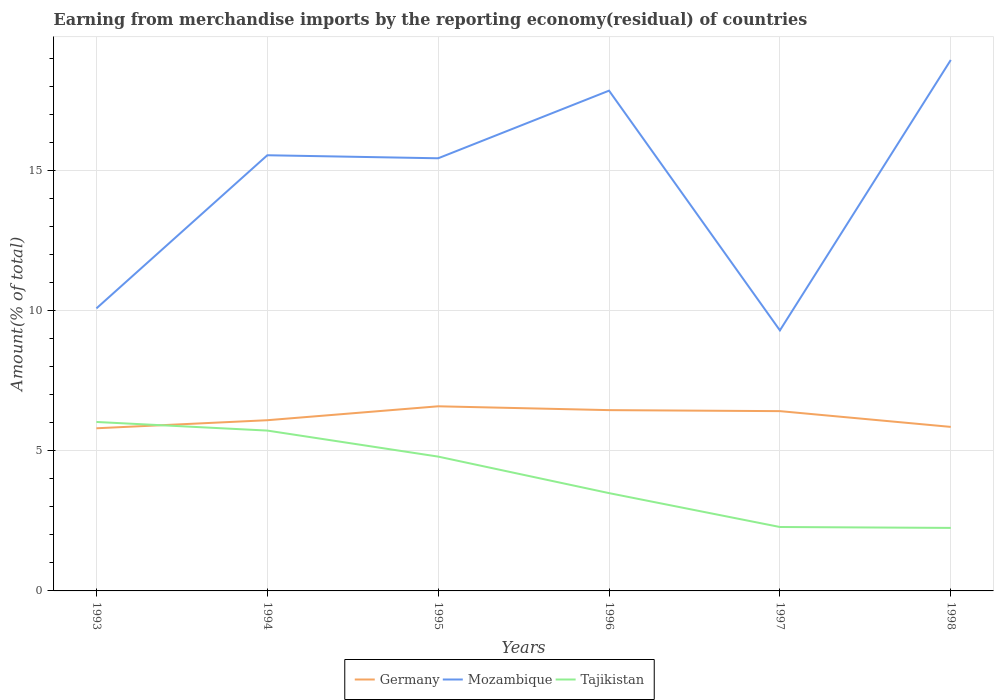Does the line corresponding to Tajikistan intersect with the line corresponding to Mozambique?
Provide a short and direct response. No. Across all years, what is the maximum percentage of amount earned from merchandise imports in Tajikistan?
Keep it short and to the point. 2.25. In which year was the percentage of amount earned from merchandise imports in Tajikistan maximum?
Provide a succinct answer. 1998. What is the total percentage of amount earned from merchandise imports in Mozambique in the graph?
Ensure brevity in your answer.  0.11. What is the difference between the highest and the second highest percentage of amount earned from merchandise imports in Mozambique?
Give a very brief answer. 9.66. What is the difference between the highest and the lowest percentage of amount earned from merchandise imports in Germany?
Your answer should be compact. 3. Is the percentage of amount earned from merchandise imports in Tajikistan strictly greater than the percentage of amount earned from merchandise imports in Mozambique over the years?
Your answer should be compact. Yes. How many lines are there?
Your answer should be very brief. 3. What is the difference between two consecutive major ticks on the Y-axis?
Ensure brevity in your answer.  5. Are the values on the major ticks of Y-axis written in scientific E-notation?
Provide a succinct answer. No. How are the legend labels stacked?
Your answer should be very brief. Horizontal. What is the title of the graph?
Make the answer very short. Earning from merchandise imports by the reporting economy(residual) of countries. What is the label or title of the Y-axis?
Give a very brief answer. Amount(% of total). What is the Amount(% of total) of Germany in 1993?
Offer a very short reply. 5.81. What is the Amount(% of total) in Mozambique in 1993?
Offer a terse response. 10.09. What is the Amount(% of total) in Tajikistan in 1993?
Your answer should be compact. 6.03. What is the Amount(% of total) in Germany in 1994?
Ensure brevity in your answer.  6.1. What is the Amount(% of total) in Mozambique in 1994?
Make the answer very short. 15.56. What is the Amount(% of total) of Tajikistan in 1994?
Offer a terse response. 5.73. What is the Amount(% of total) in Germany in 1995?
Provide a succinct answer. 6.59. What is the Amount(% of total) of Mozambique in 1995?
Your answer should be compact. 15.45. What is the Amount(% of total) of Tajikistan in 1995?
Your answer should be very brief. 4.8. What is the Amount(% of total) of Germany in 1996?
Ensure brevity in your answer.  6.46. What is the Amount(% of total) of Mozambique in 1996?
Offer a terse response. 17.87. What is the Amount(% of total) of Tajikistan in 1996?
Your answer should be compact. 3.49. What is the Amount(% of total) of Germany in 1997?
Provide a succinct answer. 6.42. What is the Amount(% of total) of Mozambique in 1997?
Give a very brief answer. 9.3. What is the Amount(% of total) of Tajikistan in 1997?
Offer a terse response. 2.28. What is the Amount(% of total) of Germany in 1998?
Keep it short and to the point. 5.86. What is the Amount(% of total) of Mozambique in 1998?
Your response must be concise. 18.96. What is the Amount(% of total) of Tajikistan in 1998?
Ensure brevity in your answer.  2.25. Across all years, what is the maximum Amount(% of total) of Germany?
Offer a very short reply. 6.59. Across all years, what is the maximum Amount(% of total) in Mozambique?
Provide a succinct answer. 18.96. Across all years, what is the maximum Amount(% of total) in Tajikistan?
Your response must be concise. 6.03. Across all years, what is the minimum Amount(% of total) of Germany?
Your answer should be compact. 5.81. Across all years, what is the minimum Amount(% of total) in Mozambique?
Give a very brief answer. 9.3. Across all years, what is the minimum Amount(% of total) of Tajikistan?
Provide a succinct answer. 2.25. What is the total Amount(% of total) in Germany in the graph?
Provide a short and direct response. 37.24. What is the total Amount(% of total) in Mozambique in the graph?
Offer a very short reply. 87.24. What is the total Amount(% of total) in Tajikistan in the graph?
Your answer should be very brief. 24.58. What is the difference between the Amount(% of total) in Germany in 1993 and that in 1994?
Keep it short and to the point. -0.29. What is the difference between the Amount(% of total) of Mozambique in 1993 and that in 1994?
Your answer should be compact. -5.47. What is the difference between the Amount(% of total) of Tajikistan in 1993 and that in 1994?
Keep it short and to the point. 0.31. What is the difference between the Amount(% of total) of Germany in 1993 and that in 1995?
Offer a very short reply. -0.79. What is the difference between the Amount(% of total) of Mozambique in 1993 and that in 1995?
Your answer should be very brief. -5.36. What is the difference between the Amount(% of total) in Tajikistan in 1993 and that in 1995?
Offer a very short reply. 1.24. What is the difference between the Amount(% of total) in Germany in 1993 and that in 1996?
Keep it short and to the point. -0.65. What is the difference between the Amount(% of total) in Mozambique in 1993 and that in 1996?
Offer a terse response. -7.78. What is the difference between the Amount(% of total) of Tajikistan in 1993 and that in 1996?
Offer a very short reply. 2.54. What is the difference between the Amount(% of total) of Germany in 1993 and that in 1997?
Your answer should be compact. -0.61. What is the difference between the Amount(% of total) of Mozambique in 1993 and that in 1997?
Give a very brief answer. 0.79. What is the difference between the Amount(% of total) of Tajikistan in 1993 and that in 1997?
Give a very brief answer. 3.75. What is the difference between the Amount(% of total) of Germany in 1993 and that in 1998?
Keep it short and to the point. -0.05. What is the difference between the Amount(% of total) in Mozambique in 1993 and that in 1998?
Offer a very short reply. -8.87. What is the difference between the Amount(% of total) in Tajikistan in 1993 and that in 1998?
Offer a very short reply. 3.78. What is the difference between the Amount(% of total) in Germany in 1994 and that in 1995?
Your answer should be compact. -0.5. What is the difference between the Amount(% of total) of Mozambique in 1994 and that in 1995?
Keep it short and to the point. 0.11. What is the difference between the Amount(% of total) of Tajikistan in 1994 and that in 1995?
Ensure brevity in your answer.  0.93. What is the difference between the Amount(% of total) of Germany in 1994 and that in 1996?
Provide a succinct answer. -0.36. What is the difference between the Amount(% of total) of Mozambique in 1994 and that in 1996?
Ensure brevity in your answer.  -2.31. What is the difference between the Amount(% of total) in Tajikistan in 1994 and that in 1996?
Offer a very short reply. 2.23. What is the difference between the Amount(% of total) in Germany in 1994 and that in 1997?
Your response must be concise. -0.32. What is the difference between the Amount(% of total) of Mozambique in 1994 and that in 1997?
Make the answer very short. 6.25. What is the difference between the Amount(% of total) in Tajikistan in 1994 and that in 1997?
Ensure brevity in your answer.  3.44. What is the difference between the Amount(% of total) in Germany in 1994 and that in 1998?
Your answer should be compact. 0.24. What is the difference between the Amount(% of total) of Mozambique in 1994 and that in 1998?
Your answer should be very brief. -3.4. What is the difference between the Amount(% of total) in Tajikistan in 1994 and that in 1998?
Make the answer very short. 3.48. What is the difference between the Amount(% of total) in Germany in 1995 and that in 1996?
Make the answer very short. 0.14. What is the difference between the Amount(% of total) in Mozambique in 1995 and that in 1996?
Provide a short and direct response. -2.41. What is the difference between the Amount(% of total) of Tajikistan in 1995 and that in 1996?
Make the answer very short. 1.3. What is the difference between the Amount(% of total) in Germany in 1995 and that in 1997?
Keep it short and to the point. 0.17. What is the difference between the Amount(% of total) in Mozambique in 1995 and that in 1997?
Offer a terse response. 6.15. What is the difference between the Amount(% of total) in Tajikistan in 1995 and that in 1997?
Offer a terse response. 2.51. What is the difference between the Amount(% of total) in Germany in 1995 and that in 1998?
Your answer should be very brief. 0.74. What is the difference between the Amount(% of total) of Mozambique in 1995 and that in 1998?
Make the answer very short. -3.51. What is the difference between the Amount(% of total) in Tajikistan in 1995 and that in 1998?
Your answer should be compact. 2.55. What is the difference between the Amount(% of total) in Germany in 1996 and that in 1997?
Your answer should be compact. 0.04. What is the difference between the Amount(% of total) of Mozambique in 1996 and that in 1997?
Keep it short and to the point. 8.56. What is the difference between the Amount(% of total) of Tajikistan in 1996 and that in 1997?
Your answer should be compact. 1.21. What is the difference between the Amount(% of total) of Germany in 1996 and that in 1998?
Your answer should be very brief. 0.6. What is the difference between the Amount(% of total) in Mozambique in 1996 and that in 1998?
Give a very brief answer. -1.1. What is the difference between the Amount(% of total) in Tajikistan in 1996 and that in 1998?
Make the answer very short. 1.24. What is the difference between the Amount(% of total) of Germany in 1997 and that in 1998?
Offer a terse response. 0.56. What is the difference between the Amount(% of total) in Mozambique in 1997 and that in 1998?
Your answer should be very brief. -9.66. What is the difference between the Amount(% of total) in Tajikistan in 1997 and that in 1998?
Offer a terse response. 0.03. What is the difference between the Amount(% of total) of Germany in 1993 and the Amount(% of total) of Mozambique in 1994?
Your response must be concise. -9.75. What is the difference between the Amount(% of total) in Germany in 1993 and the Amount(% of total) in Tajikistan in 1994?
Ensure brevity in your answer.  0.08. What is the difference between the Amount(% of total) in Mozambique in 1993 and the Amount(% of total) in Tajikistan in 1994?
Make the answer very short. 4.36. What is the difference between the Amount(% of total) of Germany in 1993 and the Amount(% of total) of Mozambique in 1995?
Keep it short and to the point. -9.64. What is the difference between the Amount(% of total) of Germany in 1993 and the Amount(% of total) of Tajikistan in 1995?
Provide a succinct answer. 1.01. What is the difference between the Amount(% of total) in Mozambique in 1993 and the Amount(% of total) in Tajikistan in 1995?
Offer a very short reply. 5.29. What is the difference between the Amount(% of total) of Germany in 1993 and the Amount(% of total) of Mozambique in 1996?
Offer a very short reply. -12.06. What is the difference between the Amount(% of total) in Germany in 1993 and the Amount(% of total) in Tajikistan in 1996?
Keep it short and to the point. 2.32. What is the difference between the Amount(% of total) in Mozambique in 1993 and the Amount(% of total) in Tajikistan in 1996?
Offer a very short reply. 6.6. What is the difference between the Amount(% of total) in Germany in 1993 and the Amount(% of total) in Mozambique in 1997?
Provide a short and direct response. -3.5. What is the difference between the Amount(% of total) in Germany in 1993 and the Amount(% of total) in Tajikistan in 1997?
Your answer should be very brief. 3.53. What is the difference between the Amount(% of total) in Mozambique in 1993 and the Amount(% of total) in Tajikistan in 1997?
Provide a succinct answer. 7.81. What is the difference between the Amount(% of total) in Germany in 1993 and the Amount(% of total) in Mozambique in 1998?
Ensure brevity in your answer.  -13.15. What is the difference between the Amount(% of total) in Germany in 1993 and the Amount(% of total) in Tajikistan in 1998?
Provide a short and direct response. 3.56. What is the difference between the Amount(% of total) in Mozambique in 1993 and the Amount(% of total) in Tajikistan in 1998?
Your answer should be very brief. 7.84. What is the difference between the Amount(% of total) in Germany in 1994 and the Amount(% of total) in Mozambique in 1995?
Your response must be concise. -9.36. What is the difference between the Amount(% of total) in Germany in 1994 and the Amount(% of total) in Tajikistan in 1995?
Provide a succinct answer. 1.3. What is the difference between the Amount(% of total) in Mozambique in 1994 and the Amount(% of total) in Tajikistan in 1995?
Make the answer very short. 10.76. What is the difference between the Amount(% of total) in Germany in 1994 and the Amount(% of total) in Mozambique in 1996?
Give a very brief answer. -11.77. What is the difference between the Amount(% of total) of Germany in 1994 and the Amount(% of total) of Tajikistan in 1996?
Give a very brief answer. 2.6. What is the difference between the Amount(% of total) of Mozambique in 1994 and the Amount(% of total) of Tajikistan in 1996?
Your response must be concise. 12.07. What is the difference between the Amount(% of total) in Germany in 1994 and the Amount(% of total) in Mozambique in 1997?
Your answer should be very brief. -3.21. What is the difference between the Amount(% of total) in Germany in 1994 and the Amount(% of total) in Tajikistan in 1997?
Your answer should be very brief. 3.81. What is the difference between the Amount(% of total) in Mozambique in 1994 and the Amount(% of total) in Tajikistan in 1997?
Your response must be concise. 13.28. What is the difference between the Amount(% of total) in Germany in 1994 and the Amount(% of total) in Mozambique in 1998?
Ensure brevity in your answer.  -12.87. What is the difference between the Amount(% of total) in Germany in 1994 and the Amount(% of total) in Tajikistan in 1998?
Your answer should be very brief. 3.85. What is the difference between the Amount(% of total) in Mozambique in 1994 and the Amount(% of total) in Tajikistan in 1998?
Give a very brief answer. 13.31. What is the difference between the Amount(% of total) of Germany in 1995 and the Amount(% of total) of Mozambique in 1996?
Ensure brevity in your answer.  -11.27. What is the difference between the Amount(% of total) in Germany in 1995 and the Amount(% of total) in Tajikistan in 1996?
Provide a short and direct response. 3.1. What is the difference between the Amount(% of total) of Mozambique in 1995 and the Amount(% of total) of Tajikistan in 1996?
Ensure brevity in your answer.  11.96. What is the difference between the Amount(% of total) of Germany in 1995 and the Amount(% of total) of Mozambique in 1997?
Your response must be concise. -2.71. What is the difference between the Amount(% of total) of Germany in 1995 and the Amount(% of total) of Tajikistan in 1997?
Keep it short and to the point. 4.31. What is the difference between the Amount(% of total) in Mozambique in 1995 and the Amount(% of total) in Tajikistan in 1997?
Offer a terse response. 13.17. What is the difference between the Amount(% of total) in Germany in 1995 and the Amount(% of total) in Mozambique in 1998?
Ensure brevity in your answer.  -12.37. What is the difference between the Amount(% of total) of Germany in 1995 and the Amount(% of total) of Tajikistan in 1998?
Offer a terse response. 4.34. What is the difference between the Amount(% of total) in Mozambique in 1995 and the Amount(% of total) in Tajikistan in 1998?
Provide a succinct answer. 13.2. What is the difference between the Amount(% of total) of Germany in 1996 and the Amount(% of total) of Mozambique in 1997?
Your answer should be very brief. -2.85. What is the difference between the Amount(% of total) in Germany in 1996 and the Amount(% of total) in Tajikistan in 1997?
Make the answer very short. 4.17. What is the difference between the Amount(% of total) of Mozambique in 1996 and the Amount(% of total) of Tajikistan in 1997?
Provide a short and direct response. 15.58. What is the difference between the Amount(% of total) of Germany in 1996 and the Amount(% of total) of Mozambique in 1998?
Offer a very short reply. -12.51. What is the difference between the Amount(% of total) in Germany in 1996 and the Amount(% of total) in Tajikistan in 1998?
Provide a succinct answer. 4.21. What is the difference between the Amount(% of total) in Mozambique in 1996 and the Amount(% of total) in Tajikistan in 1998?
Offer a very short reply. 15.62. What is the difference between the Amount(% of total) in Germany in 1997 and the Amount(% of total) in Mozambique in 1998?
Make the answer very short. -12.54. What is the difference between the Amount(% of total) of Germany in 1997 and the Amount(% of total) of Tajikistan in 1998?
Your answer should be compact. 4.17. What is the difference between the Amount(% of total) in Mozambique in 1997 and the Amount(% of total) in Tajikistan in 1998?
Give a very brief answer. 7.05. What is the average Amount(% of total) of Germany per year?
Give a very brief answer. 6.21. What is the average Amount(% of total) of Mozambique per year?
Your answer should be very brief. 14.54. What is the average Amount(% of total) in Tajikistan per year?
Your response must be concise. 4.1. In the year 1993, what is the difference between the Amount(% of total) in Germany and Amount(% of total) in Mozambique?
Make the answer very short. -4.28. In the year 1993, what is the difference between the Amount(% of total) of Germany and Amount(% of total) of Tajikistan?
Keep it short and to the point. -0.23. In the year 1993, what is the difference between the Amount(% of total) of Mozambique and Amount(% of total) of Tajikistan?
Your answer should be very brief. 4.06. In the year 1994, what is the difference between the Amount(% of total) in Germany and Amount(% of total) in Mozambique?
Ensure brevity in your answer.  -9.46. In the year 1994, what is the difference between the Amount(% of total) of Germany and Amount(% of total) of Tajikistan?
Make the answer very short. 0.37. In the year 1994, what is the difference between the Amount(% of total) in Mozambique and Amount(% of total) in Tajikistan?
Provide a short and direct response. 9.83. In the year 1995, what is the difference between the Amount(% of total) of Germany and Amount(% of total) of Mozambique?
Your answer should be compact. -8.86. In the year 1995, what is the difference between the Amount(% of total) of Germany and Amount(% of total) of Tajikistan?
Make the answer very short. 1.8. In the year 1995, what is the difference between the Amount(% of total) of Mozambique and Amount(% of total) of Tajikistan?
Your response must be concise. 10.65. In the year 1996, what is the difference between the Amount(% of total) of Germany and Amount(% of total) of Mozambique?
Offer a terse response. -11.41. In the year 1996, what is the difference between the Amount(% of total) in Germany and Amount(% of total) in Tajikistan?
Offer a very short reply. 2.96. In the year 1996, what is the difference between the Amount(% of total) of Mozambique and Amount(% of total) of Tajikistan?
Offer a very short reply. 14.37. In the year 1997, what is the difference between the Amount(% of total) of Germany and Amount(% of total) of Mozambique?
Keep it short and to the point. -2.88. In the year 1997, what is the difference between the Amount(% of total) of Germany and Amount(% of total) of Tajikistan?
Offer a very short reply. 4.14. In the year 1997, what is the difference between the Amount(% of total) of Mozambique and Amount(% of total) of Tajikistan?
Provide a short and direct response. 7.02. In the year 1998, what is the difference between the Amount(% of total) of Germany and Amount(% of total) of Mozambique?
Offer a terse response. -13.1. In the year 1998, what is the difference between the Amount(% of total) of Germany and Amount(% of total) of Tajikistan?
Give a very brief answer. 3.61. In the year 1998, what is the difference between the Amount(% of total) in Mozambique and Amount(% of total) in Tajikistan?
Your answer should be compact. 16.71. What is the ratio of the Amount(% of total) of Germany in 1993 to that in 1994?
Provide a short and direct response. 0.95. What is the ratio of the Amount(% of total) of Mozambique in 1993 to that in 1994?
Give a very brief answer. 0.65. What is the ratio of the Amount(% of total) of Tajikistan in 1993 to that in 1994?
Your answer should be compact. 1.05. What is the ratio of the Amount(% of total) of Germany in 1993 to that in 1995?
Make the answer very short. 0.88. What is the ratio of the Amount(% of total) in Mozambique in 1993 to that in 1995?
Your response must be concise. 0.65. What is the ratio of the Amount(% of total) in Tajikistan in 1993 to that in 1995?
Give a very brief answer. 1.26. What is the ratio of the Amount(% of total) in Germany in 1993 to that in 1996?
Provide a short and direct response. 0.9. What is the ratio of the Amount(% of total) of Mozambique in 1993 to that in 1996?
Keep it short and to the point. 0.56. What is the ratio of the Amount(% of total) in Tajikistan in 1993 to that in 1996?
Your response must be concise. 1.73. What is the ratio of the Amount(% of total) in Germany in 1993 to that in 1997?
Provide a short and direct response. 0.9. What is the ratio of the Amount(% of total) of Mozambique in 1993 to that in 1997?
Ensure brevity in your answer.  1.08. What is the ratio of the Amount(% of total) in Tajikistan in 1993 to that in 1997?
Your response must be concise. 2.64. What is the ratio of the Amount(% of total) of Mozambique in 1993 to that in 1998?
Offer a terse response. 0.53. What is the ratio of the Amount(% of total) of Tajikistan in 1993 to that in 1998?
Ensure brevity in your answer.  2.68. What is the ratio of the Amount(% of total) of Germany in 1994 to that in 1995?
Keep it short and to the point. 0.92. What is the ratio of the Amount(% of total) of Tajikistan in 1994 to that in 1995?
Offer a terse response. 1.19. What is the ratio of the Amount(% of total) of Germany in 1994 to that in 1996?
Provide a short and direct response. 0.94. What is the ratio of the Amount(% of total) of Mozambique in 1994 to that in 1996?
Give a very brief answer. 0.87. What is the ratio of the Amount(% of total) of Tajikistan in 1994 to that in 1996?
Your answer should be compact. 1.64. What is the ratio of the Amount(% of total) of Germany in 1994 to that in 1997?
Provide a succinct answer. 0.95. What is the ratio of the Amount(% of total) of Mozambique in 1994 to that in 1997?
Your answer should be very brief. 1.67. What is the ratio of the Amount(% of total) in Tajikistan in 1994 to that in 1997?
Your answer should be compact. 2.51. What is the ratio of the Amount(% of total) of Germany in 1994 to that in 1998?
Offer a terse response. 1.04. What is the ratio of the Amount(% of total) of Mozambique in 1994 to that in 1998?
Your answer should be very brief. 0.82. What is the ratio of the Amount(% of total) of Tajikistan in 1994 to that in 1998?
Ensure brevity in your answer.  2.54. What is the ratio of the Amount(% of total) in Germany in 1995 to that in 1996?
Give a very brief answer. 1.02. What is the ratio of the Amount(% of total) of Mozambique in 1995 to that in 1996?
Your answer should be very brief. 0.86. What is the ratio of the Amount(% of total) in Tajikistan in 1995 to that in 1996?
Provide a succinct answer. 1.37. What is the ratio of the Amount(% of total) in Germany in 1995 to that in 1997?
Provide a succinct answer. 1.03. What is the ratio of the Amount(% of total) of Mozambique in 1995 to that in 1997?
Your response must be concise. 1.66. What is the ratio of the Amount(% of total) in Tajikistan in 1995 to that in 1997?
Your answer should be very brief. 2.1. What is the ratio of the Amount(% of total) in Germany in 1995 to that in 1998?
Give a very brief answer. 1.13. What is the ratio of the Amount(% of total) of Mozambique in 1995 to that in 1998?
Provide a short and direct response. 0.81. What is the ratio of the Amount(% of total) in Tajikistan in 1995 to that in 1998?
Offer a terse response. 2.13. What is the ratio of the Amount(% of total) in Germany in 1996 to that in 1997?
Keep it short and to the point. 1.01. What is the ratio of the Amount(% of total) of Mozambique in 1996 to that in 1997?
Provide a succinct answer. 1.92. What is the ratio of the Amount(% of total) of Tajikistan in 1996 to that in 1997?
Your answer should be very brief. 1.53. What is the ratio of the Amount(% of total) in Germany in 1996 to that in 1998?
Your answer should be compact. 1.1. What is the ratio of the Amount(% of total) in Mozambique in 1996 to that in 1998?
Make the answer very short. 0.94. What is the ratio of the Amount(% of total) of Tajikistan in 1996 to that in 1998?
Your response must be concise. 1.55. What is the ratio of the Amount(% of total) in Germany in 1997 to that in 1998?
Give a very brief answer. 1.1. What is the ratio of the Amount(% of total) of Mozambique in 1997 to that in 1998?
Your answer should be very brief. 0.49. What is the ratio of the Amount(% of total) in Tajikistan in 1997 to that in 1998?
Provide a succinct answer. 1.01. What is the difference between the highest and the second highest Amount(% of total) of Germany?
Provide a succinct answer. 0.14. What is the difference between the highest and the second highest Amount(% of total) of Mozambique?
Offer a terse response. 1.1. What is the difference between the highest and the second highest Amount(% of total) of Tajikistan?
Provide a short and direct response. 0.31. What is the difference between the highest and the lowest Amount(% of total) of Germany?
Offer a terse response. 0.79. What is the difference between the highest and the lowest Amount(% of total) in Mozambique?
Your answer should be very brief. 9.66. What is the difference between the highest and the lowest Amount(% of total) in Tajikistan?
Your answer should be compact. 3.78. 